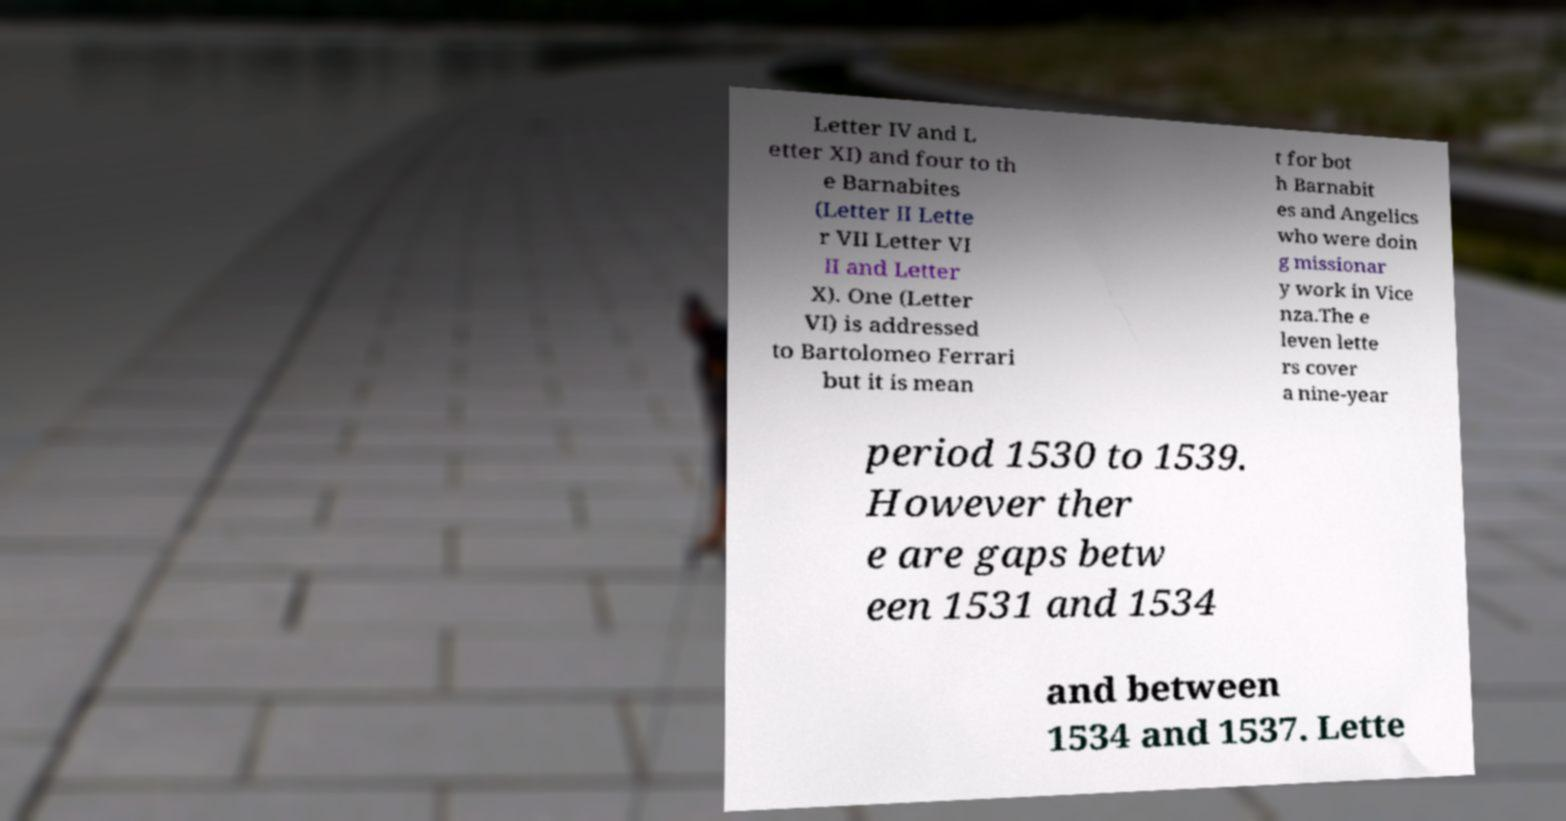Please identify and transcribe the text found in this image. Letter IV and L etter XI) and four to th e Barnabites (Letter II Lette r VII Letter VI II and Letter X). One (Letter VI) is addressed to Bartolomeo Ferrari but it is mean t for bot h Barnabit es and Angelics who were doin g missionar y work in Vice nza.The e leven lette rs cover a nine-year period 1530 to 1539. However ther e are gaps betw een 1531 and 1534 and between 1534 and 1537. Lette 